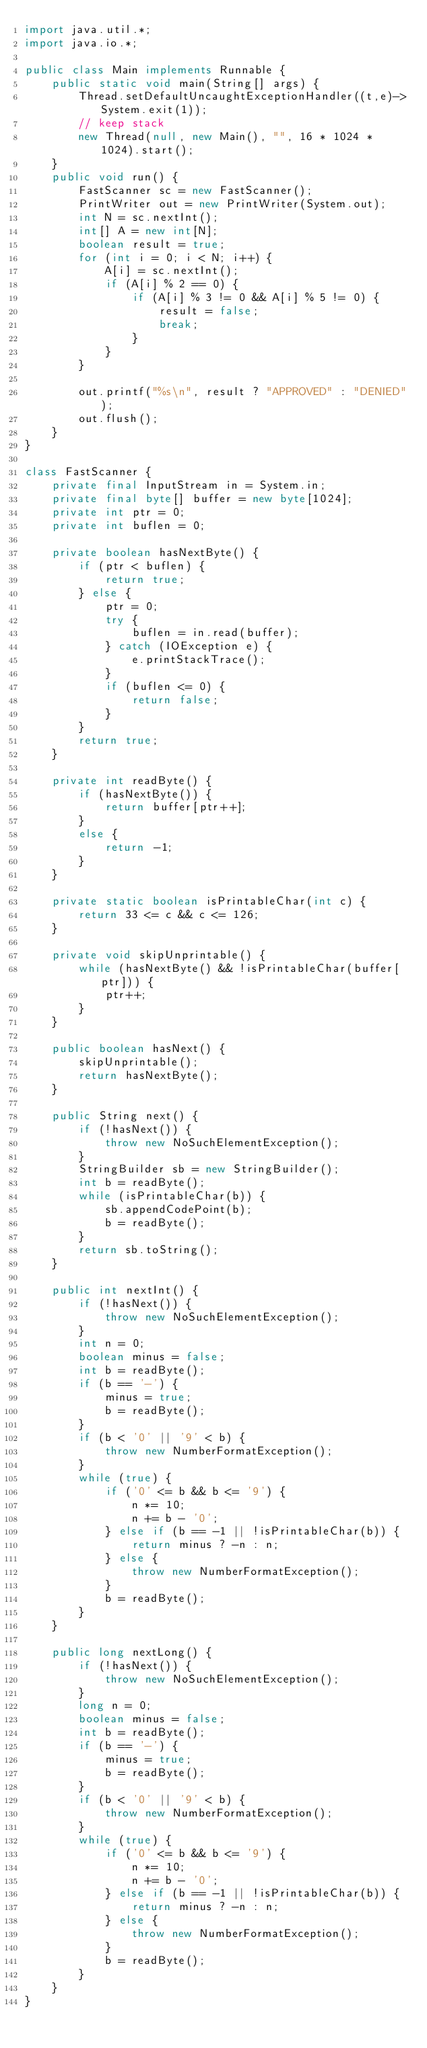Convert code to text. <code><loc_0><loc_0><loc_500><loc_500><_Java_>import java.util.*;
import java.io.*;

public class Main implements Runnable {
    public static void main(String[] args) {
        Thread.setDefaultUncaughtExceptionHandler((t,e)->System.exit(1));
        // keep stack
        new Thread(null, new Main(), "", 16 * 1024 * 1024).start();
    }
    public void run() {
        FastScanner sc = new FastScanner();
        PrintWriter out = new PrintWriter(System.out);
        int N = sc.nextInt();
        int[] A = new int[N];
        boolean result = true;
        for (int i = 0; i < N; i++) {
            A[i] = sc.nextInt();
            if (A[i] % 2 == 0) {
                if (A[i] % 3 != 0 && A[i] % 5 != 0) {
                    result = false;
                    break;
                }
            }
        }

        out.printf("%s\n", result ? "APPROVED" : "DENIED");
        out.flush();
    }
}

class FastScanner {
    private final InputStream in = System.in;
    private final byte[] buffer = new byte[1024];
    private int ptr = 0;
    private int buflen = 0;

    private boolean hasNextByte() {
        if (ptr < buflen) {
            return true;
        } else {
            ptr = 0;
            try {
                buflen = in.read(buffer);
            } catch (IOException e) {
                e.printStackTrace();
            }
            if (buflen <= 0) {
                return false;
            }
        }
        return true;
    }

    private int readByte() {
        if (hasNextByte()) {
            return buffer[ptr++];
        }
        else {
            return -1;
        }
    }

    private static boolean isPrintableChar(int c) {
        return 33 <= c && c <= 126;
    }

    private void skipUnprintable() {
        while (hasNextByte() && !isPrintableChar(buffer[ptr])) {
            ptr++;
        }
    }

    public boolean hasNext() {
        skipUnprintable();
        return hasNextByte();
    }

    public String next() {
        if (!hasNext()) {
            throw new NoSuchElementException();
        }
        StringBuilder sb = new StringBuilder();
        int b = readByte();
        while (isPrintableChar(b)) {
            sb.appendCodePoint(b);
            b = readByte();
        }
        return sb.toString();
    }

    public int nextInt() {
        if (!hasNext()) {
            throw new NoSuchElementException();
        }
        int n = 0;
        boolean minus = false;
        int b = readByte();
        if (b == '-') {
            minus = true;
            b = readByte();
        }
        if (b < '0' || '9' < b) {
            throw new NumberFormatException();
        }
        while (true) {
            if ('0' <= b && b <= '9') {
                n *= 10;
                n += b - '0';
            } else if (b == -1 || !isPrintableChar(b)) {
                return minus ? -n : n;
            } else {
                throw new NumberFormatException();
            }
            b = readByte();
        }
    }

    public long nextLong() {
        if (!hasNext()) {
            throw new NoSuchElementException();
        }
        long n = 0;
        boolean minus = false;
        int b = readByte();
        if (b == '-') {
            minus = true;
            b = readByte();
        }
        if (b < '0' || '9' < b) {
            throw new NumberFormatException();
        }
        while (true) {
            if ('0' <= b && b <= '9') {
                n *= 10;
                n += b - '0';
            } else if (b == -1 || !isPrintableChar(b)) {
                return minus ? -n : n;
            } else {
                throw new NumberFormatException();
            }
            b = readByte();
        }
    }
}
</code> 